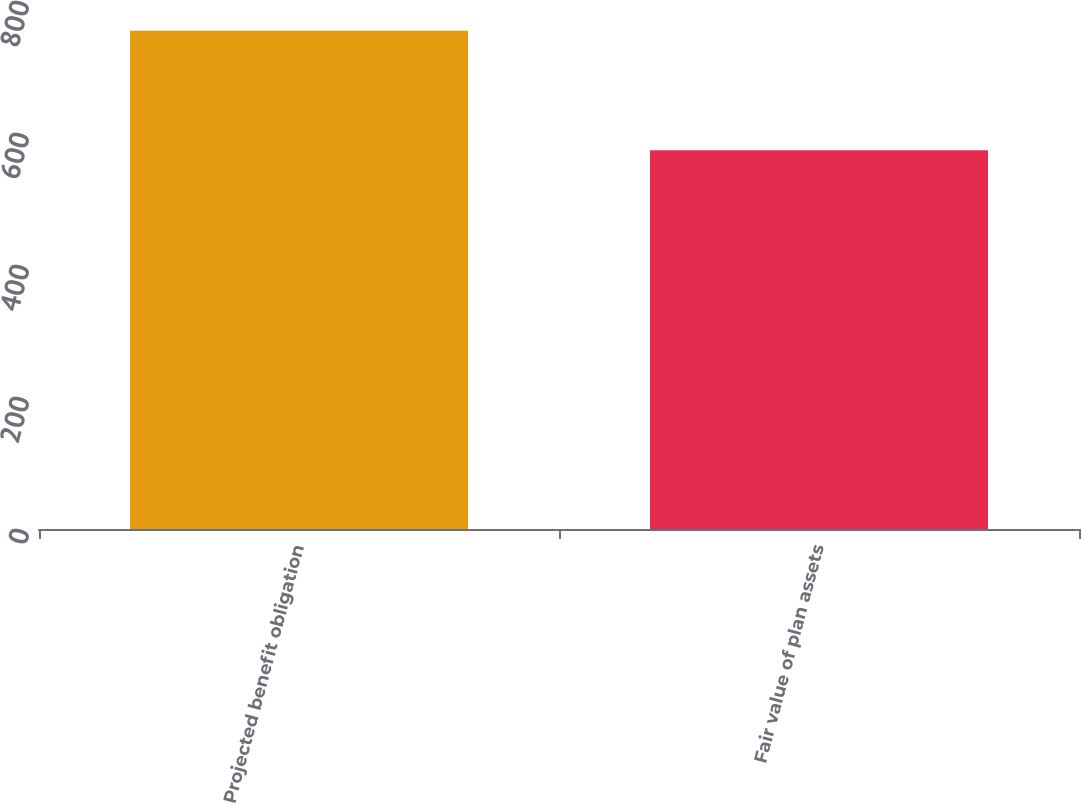<chart> <loc_0><loc_0><loc_500><loc_500><bar_chart><fcel>Projected benefit obligation<fcel>Fair value of plan assets<nl><fcel>755<fcel>574<nl></chart> 